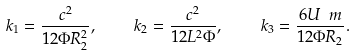Convert formula to latex. <formula><loc_0><loc_0><loc_500><loc_500>k _ { 1 } = \frac { c ^ { 2 } } { 1 2 \Phi R _ { 2 } ^ { 2 } } , \quad k _ { 2 } = \frac { c ^ { 2 } } { 1 2 L ^ { 2 } \Phi } , \quad k _ { 3 } = \frac { 6 U \ m } { 1 2 \Phi R _ { 2 } } .</formula> 